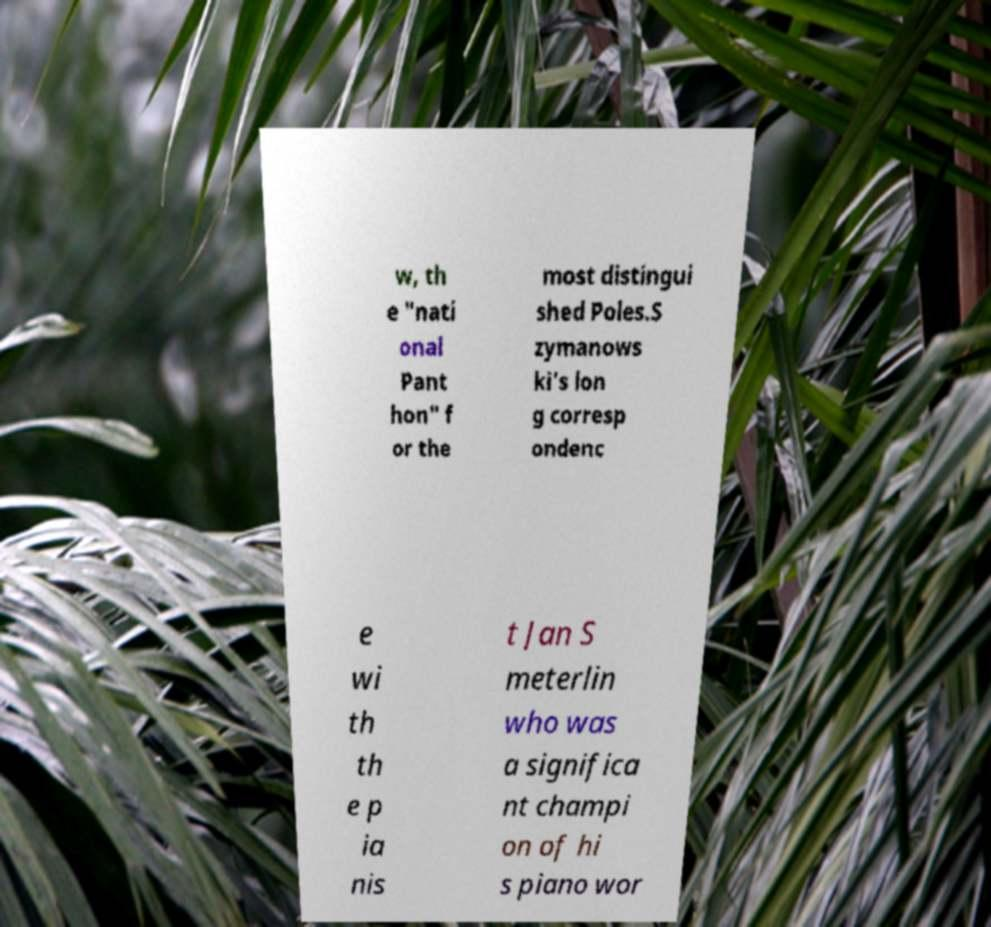For documentation purposes, I need the text within this image transcribed. Could you provide that? w, th e "nati onal Pant hon" f or the most distingui shed Poles.S zymanows ki's lon g corresp ondenc e wi th th e p ia nis t Jan S meterlin who was a significa nt champi on of hi s piano wor 